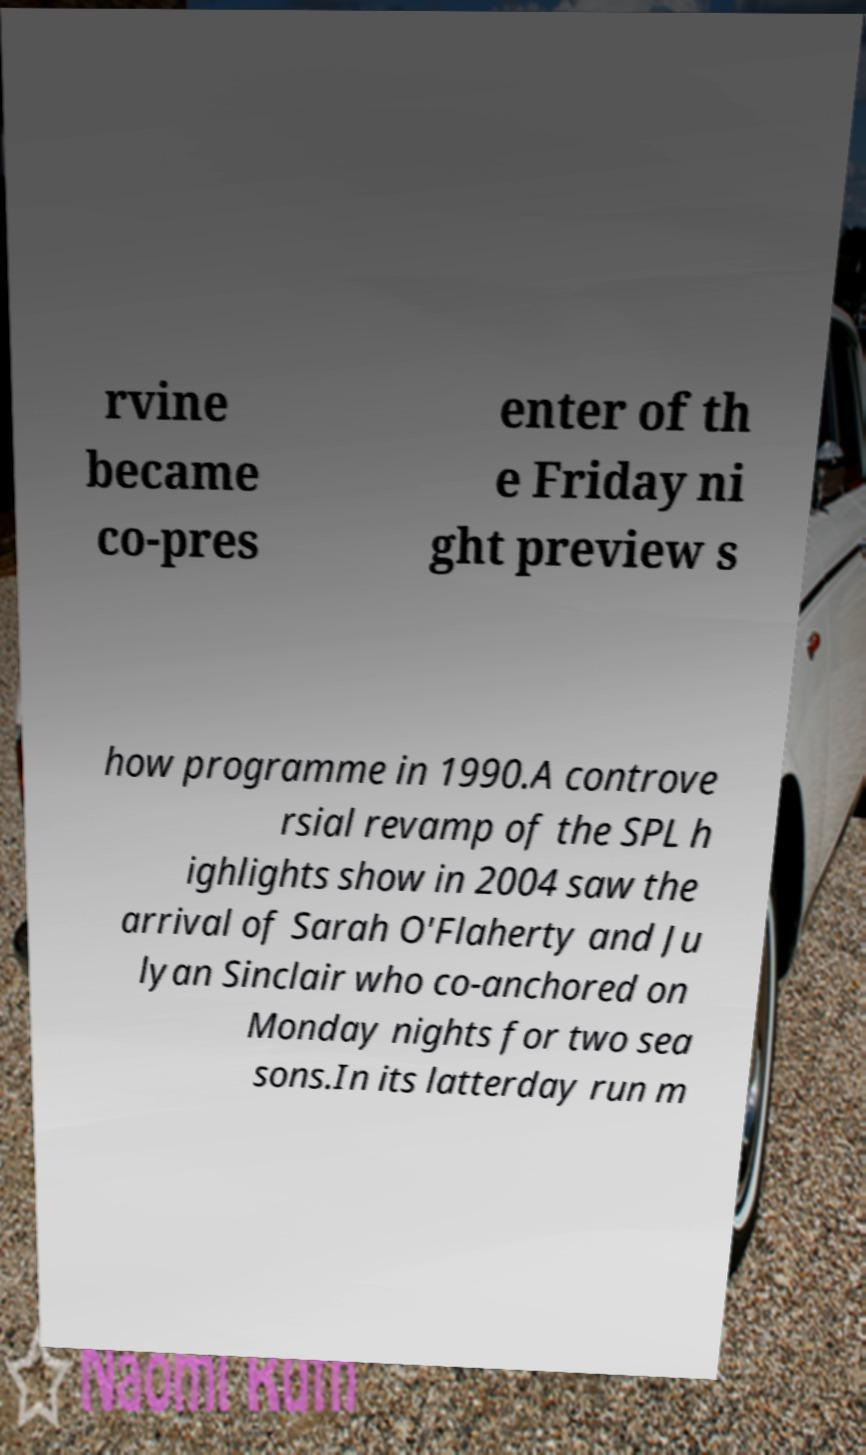Can you accurately transcribe the text from the provided image for me? rvine became co-pres enter of th e Friday ni ght preview s how programme in 1990.A controve rsial revamp of the SPL h ighlights show in 2004 saw the arrival of Sarah O'Flaherty and Ju lyan Sinclair who co-anchored on Monday nights for two sea sons.In its latterday run m 